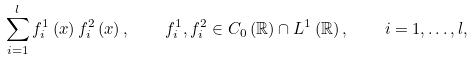<formula> <loc_0><loc_0><loc_500><loc_500>\sum _ { i = 1 } ^ { l } f _ { i } ^ { 1 } \left ( x \right ) f _ { i } ^ { 2 } \left ( x \right ) , \quad f ^ { 1 } _ { i } , f ^ { 2 } _ { i } \in C _ { 0 } \left ( \mathbb { R } \right ) \cap L ^ { 1 } \left ( \mathbb { R } \right ) , \quad i = 1 , \dots , l ,</formula> 